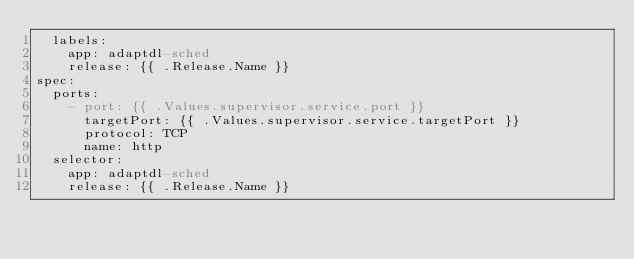Convert code to text. <code><loc_0><loc_0><loc_500><loc_500><_YAML_>  labels:
    app: adaptdl-sched
    release: {{ .Release.Name }}
spec:
  ports:
    - port: {{ .Values.supervisor.service.port }}
      targetPort: {{ .Values.supervisor.service.targetPort }}
      protocol: TCP
      name: http
  selector:
    app: adaptdl-sched
    release: {{ .Release.Name }}
</code> 